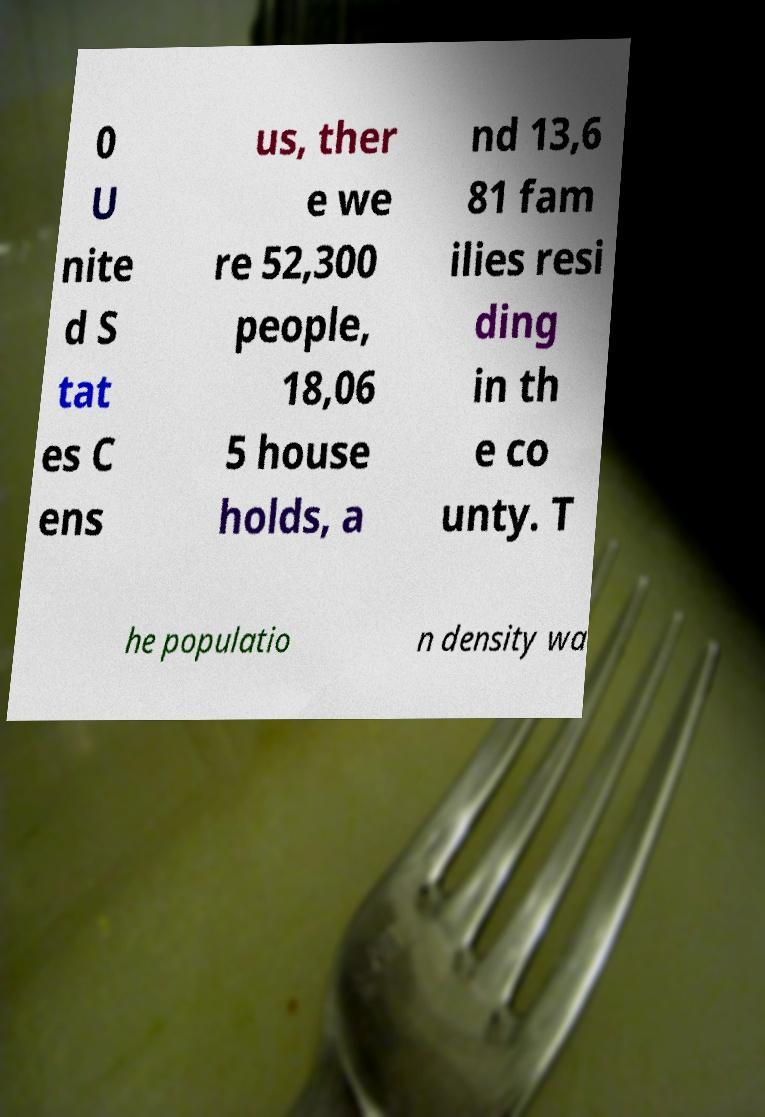Can you accurately transcribe the text from the provided image for me? 0 U nite d S tat es C ens us, ther e we re 52,300 people, 18,06 5 house holds, a nd 13,6 81 fam ilies resi ding in th e co unty. T he populatio n density wa 